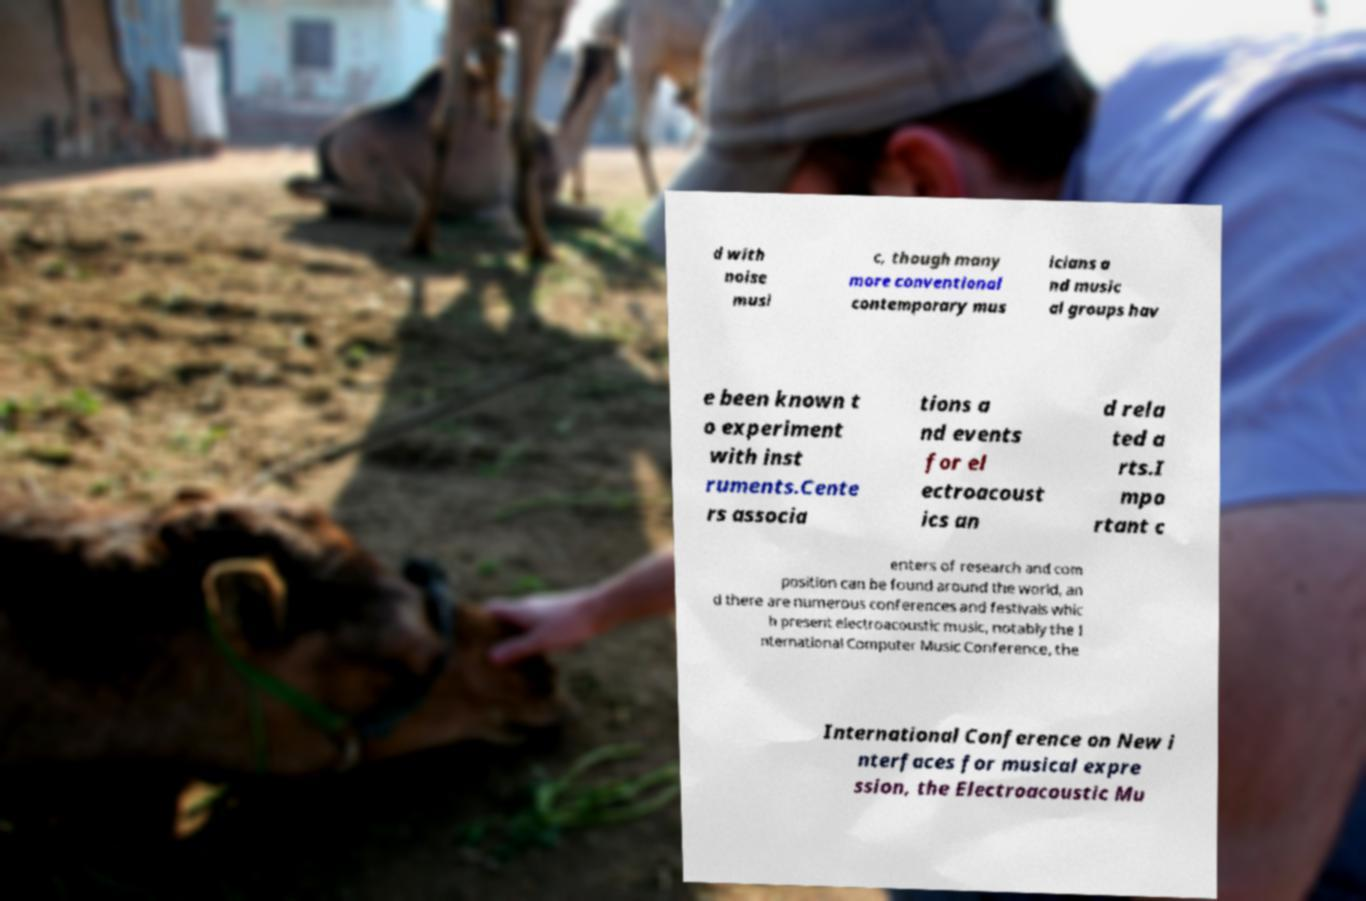Please read and relay the text visible in this image. What does it say? d with noise musi c, though many more conventional contemporary mus icians a nd music al groups hav e been known t o experiment with inst ruments.Cente rs associa tions a nd events for el ectroacoust ics an d rela ted a rts.I mpo rtant c enters of research and com position can be found around the world, an d there are numerous conferences and festivals whic h present electroacoustic music, notably the I nternational Computer Music Conference, the International Conference on New i nterfaces for musical expre ssion, the Electroacoustic Mu 